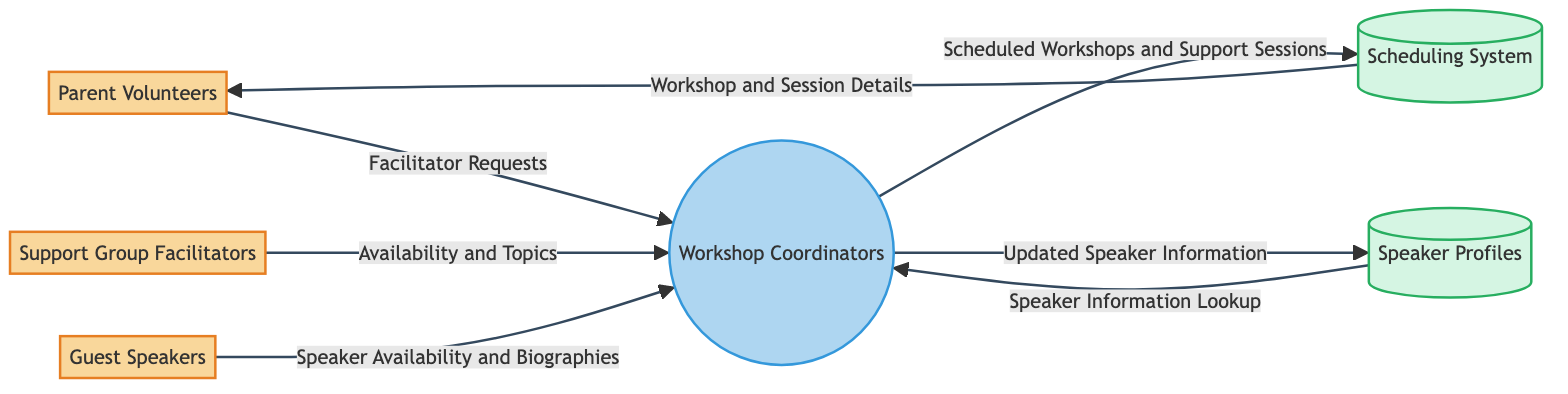What are the external entities present in the diagram? The external entities listed in the diagram include Parent Volunteers, Support Group Facilitators, and Guest Speakers. These are explicitly shown as unique components in the diagram, representing individuals or groups outside the main workflow.
Answer: Parent Volunteers, Support Group Facilitators, Guest Speakers How many processes are depicted in the diagram? The diagram illustrates a single process, labeled as Workshop Coordinators. This can be identified as the only process node that connects with various entities and data stores.
Answer: 1 What data flows from Support Group Facilitators to Workshop Coordinators? The data flowing from Support Group Facilitators to Workshop Coordinators is described as Availability and Topics. This is visualized as an arrow connecting the two nodes indicating the information shared.
Answer: Availability and Topics Which data store receives scheduled workshops and support sessions? The scheduled workshops and support sessions are sent to the Scheduling System, as shown in the diagram. This is indicated by the arrow between Workshop Coordinators and Scheduling System.
Answer: Scheduling System What information do Guest Speakers provide to Workshop Coordinators? Guest Speakers provide Speaker Availability and Biographies to Workshop Coordinators. This is clearly shown in the diagram with an arrow directing this specific data flow towards the Workshop Coordinators.
Answer: Speaker Availability and Biographies What is the output of the Scheduling System to Parent Volunteers? The output from the Scheduling System to Parent Volunteers consists of Workshop and Session Details, which is depicted in the diagram as data flowing from the Scheduling System towards the Parent Volunteers.
Answer: Workshop and Session Details Which data flow indicates an update of speaker information? The data flow that indicates an update of speaker information is labeled Updated Speaker Information, flowing from Workshop Coordinators to Speaker Profiles. This is shown with a directional arrow in the diagram highlighting this specific interaction.
Answer: Updated Speaker Information How many data stores are included in the diagram? The diagram includes two data stores, which are Scheduling System and Speaker Profiles. This is easily recognizable as the only nodes categorized as data stores in the diagram's structure.
Answer: 2 What is the purpose of the Speaker Profiles data store? The purpose of the Speaker Profiles data store is to store updated speaker information and facilitate speaker information lookup, as indicated by the arrows connecting it to the Workshop Coordinators and its functions described in the diagram.
Answer: Store updated speaker information and facilitate lookups 